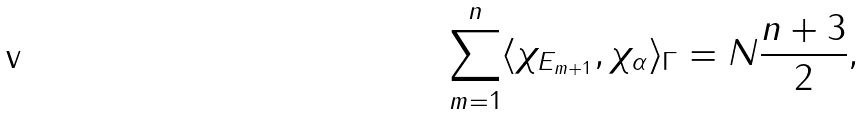Convert formula to latex. <formula><loc_0><loc_0><loc_500><loc_500>\sum _ { m = 1 } ^ { n } \langle \chi _ { E _ { m + 1 } } , \chi _ { \alpha } \rangle _ { \Gamma } = N \frac { n + 3 } { 2 } ,</formula> 